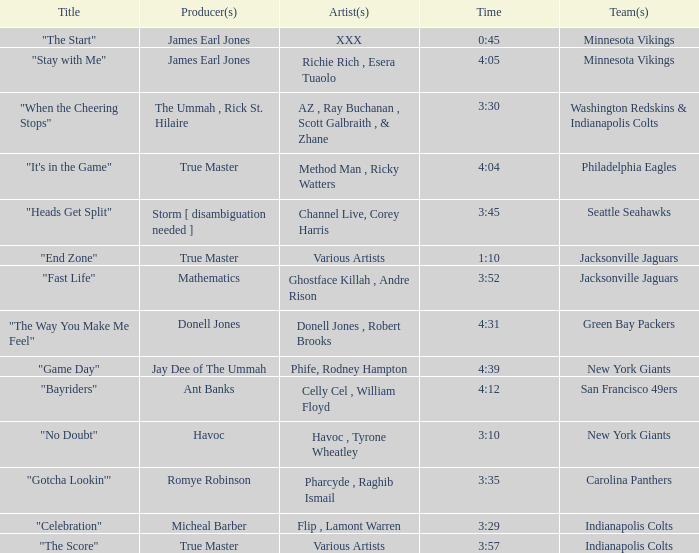Who is the creator of the new york giants track "no doubt"? Havoc , Tyrone Wheatley. 